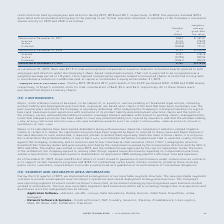According to Roper Technologies's financial document, What was the compensation expense related to outstanding shares of restricted stock held by employees and directors during 2019? Based on the financial document, the answer is $72.5. Also, How long does restricted stock grants generally vest over? Based on the financial document, the answer is a period of 1 to 4 years. Also, What was the total unrecognized compensation expense related to nonvested awards granted during fiscal 2019? According to the financial document, $77.9. The relevant text states: "At December 31, 2019, there was $77.9 of total unrecognized compensation expense related to nonvested awards granted to both employees and..." Also, can you calculate: What is the ratio of compensation expense related to outstanding shares of restricted stock during 2018 to the total price of restricted stock shares granted between 2017 and 2018?  To answer this question, I need to perform calculations using the financial data. The calculation is: 109.7/(0.41*278.29) , which equals 0.96. This is based on the information: "Granted 0.410 278.29 Granted 0.410 278.29 Granted 0.410 278.29..." The key data points involved are: 0.41, 109.7, 278.29. Also, can you calculate: What is the percentage change in the total price of nonvested shares from December 31, 2018, to 2019? To answer this question, I need to perform calculations using the financial data. The calculation is: ((0.709*275.00)-(0.739*225.93))/(0.739*225.93) , which equals 16.78 (percentage). This is based on the information: "Nonvested at December 31, 2018 0.739 $ 225.93 Nonvested at December 31, 2018 0.739 $ 225.93 Nonvested at December 31, 2019 0.709 $ 275.00 Nonvested at December 31, 2019 0.709 $ 275.00..." The key data points involved are: 0.709, 0.739, 225.93. Also, can you calculate: What is the total price of shares that were forfeited between 2018 and 2019? Based on the calculation: 0.061*225.23 , the result is 13.74 (in millions). This is based on the information: "Forfeited (0.061) 225.23 Forfeited (0.061) 225.23..." The key data points involved are: 0.061, 225.23. 